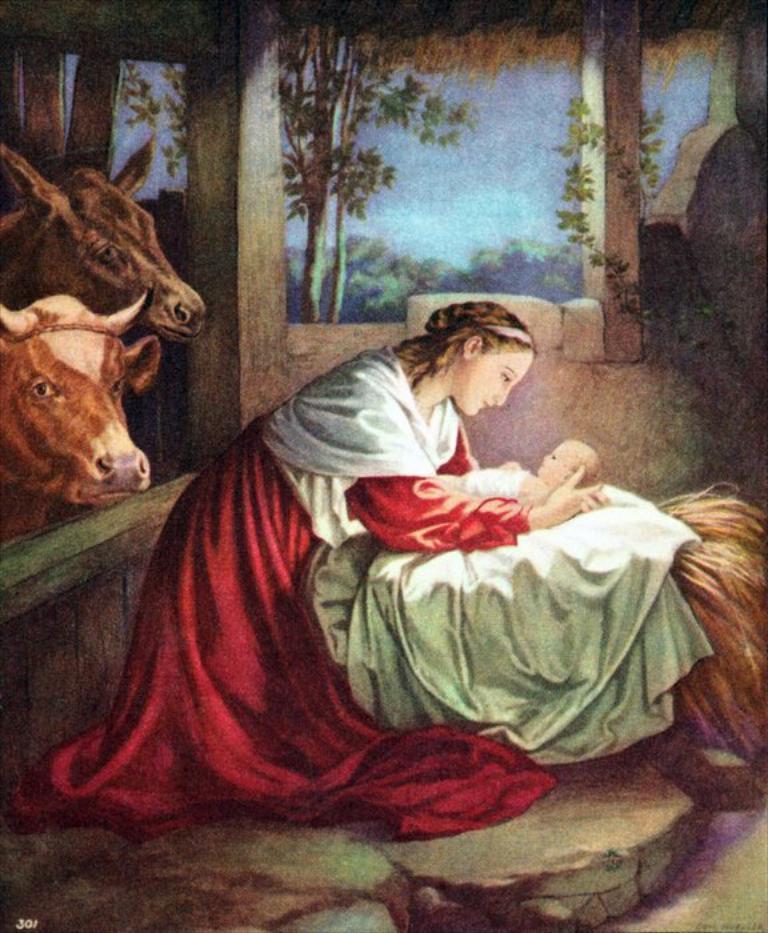Describe this image in one or two sentences. In the image there is a painting of a woman in red dress holding a baby and on the left side there are cows and in the back there is wall followed by trees in the background. 